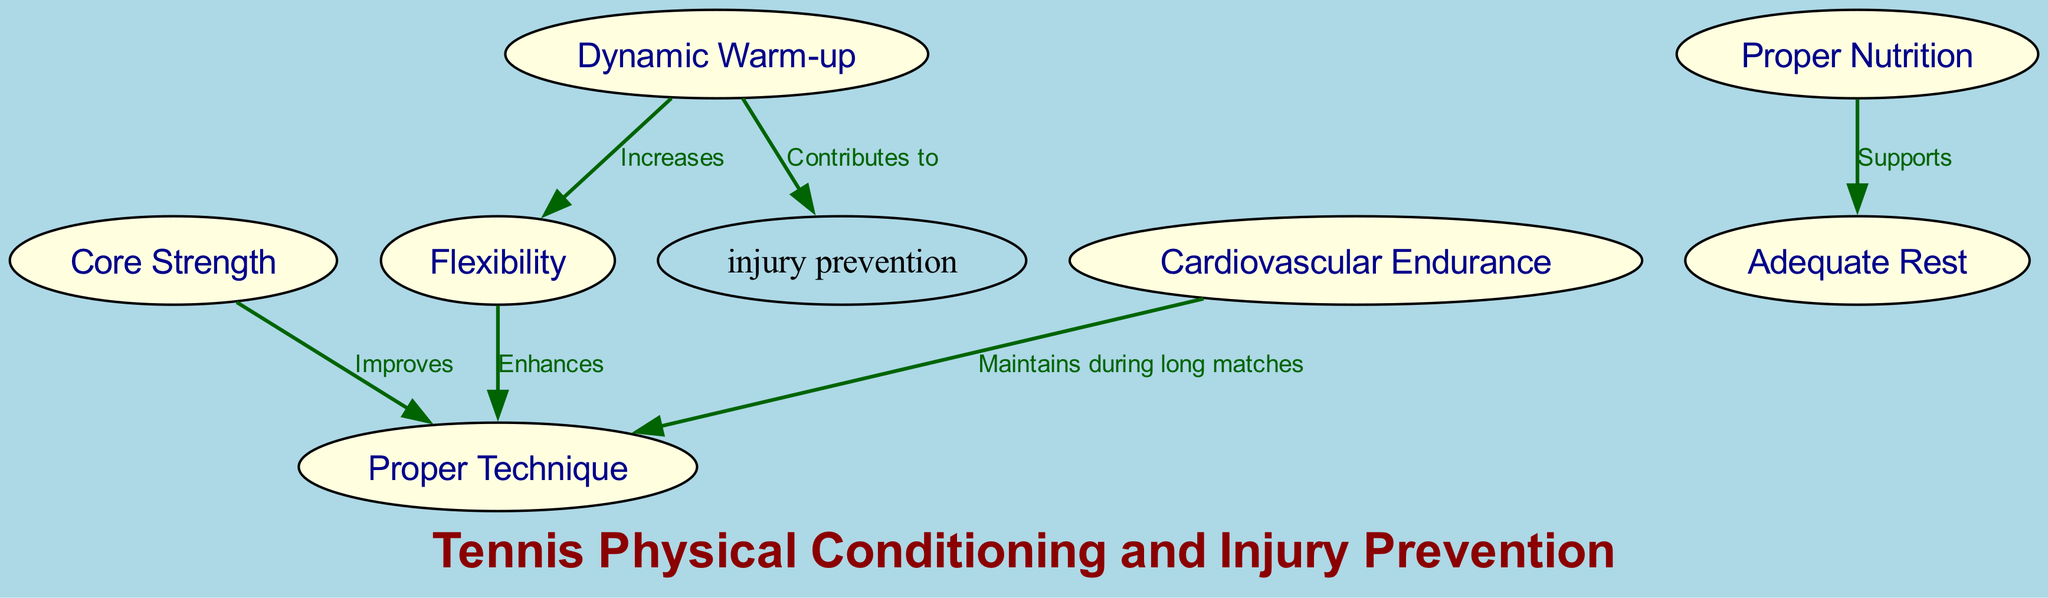What are the nodes shown in the diagram? The diagram contains the following nodes: Core Strength, Flexibility, Cardiovascular Endurance, Proper Nutrition, Adequate Rest, Proper Technique, Dynamic Warm-up. These elements represent different aspects of physical conditioning and injury prevention for tennis players.
Answer: Core Strength, Flexibility, Cardiovascular Endurance, Proper Nutrition, Adequate Rest, Proper Technique, Dynamic Warm-up How many edges are in the diagram? The diagram has six edges, which represent the relationships between the nodes. Each edge connects a source node to a target node with a particular relationship, illustrating the connections between different aspects of conditioning and injury prevention.
Answer: 6 Which node increases flexibility? The edge going from the Dynamic Warm-up node to the Flexibility node indicates that a dynamic warm-up increases flexibility, emphasizing its importance in physical conditioning for tennis players.
Answer: Dynamic Warm-up What does Proper Nutrition support? The edge from Proper Nutrition to Adequate Rest indicates that Proper Nutrition supports Adequate Rest, showing the connection between good nutrition and recovery in sports performance.
Answer: Adequate Rest How does Core Strength influence Proper Technique? The edge connecting the Core Strength node to the Proper Technique node states that Core Strength improves Proper Technique. This indicates that having a strong core can enhance overall technique in tennis.
Answer: Improves What do Dynamic Warm-ups contribute to? The diagram shows an edge leading from Dynamic Warm-up to Injury Prevention, highlighting the role of warm-ups in preventing injuries, which is vital for tennis players.
Answer: Injury Prevention Which aspect maintains technique during long matches? The edge linking Cardiovascular Endurance to Proper Technique notes that Cardiovascular Endurance maintains technique during long matches, suggesting that stamina is crucial for performance consistency.
Answer: Maintains during long matches 